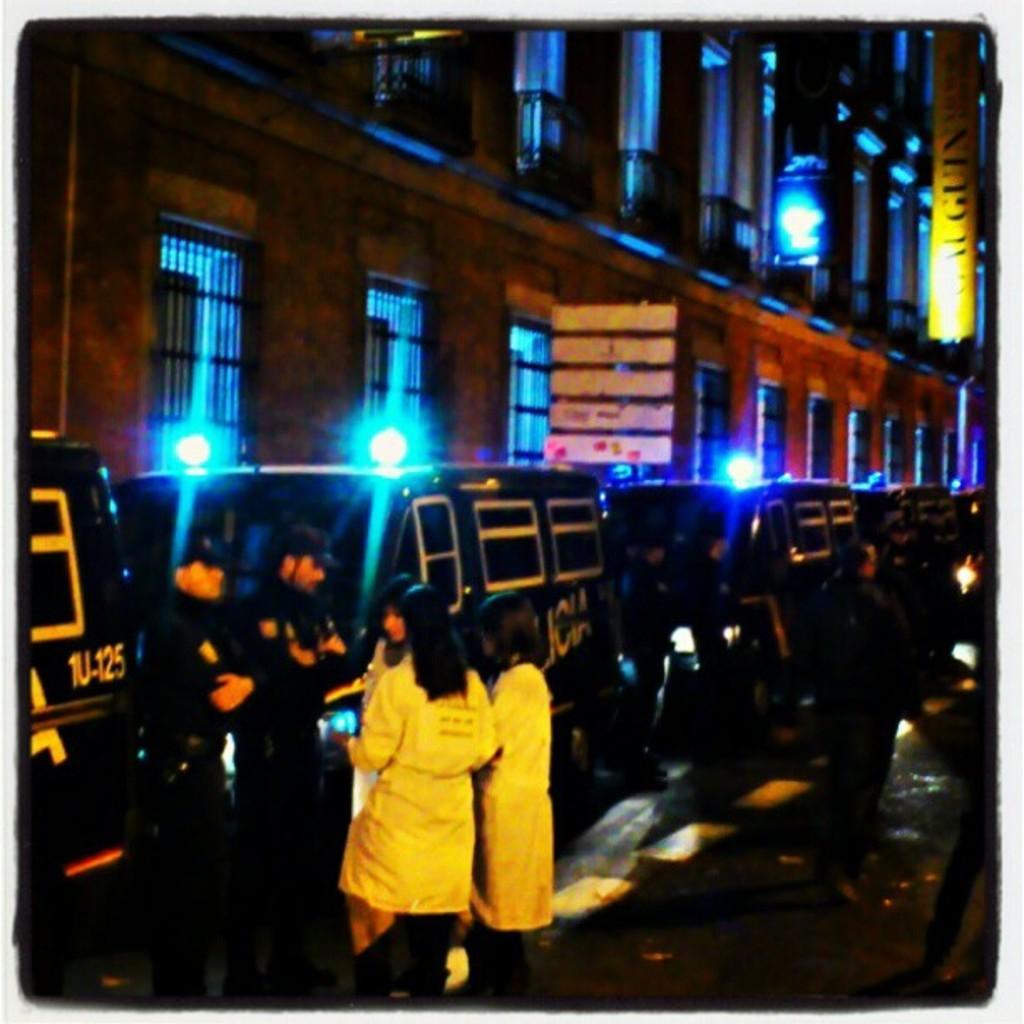Please provide a concise description of this image. This picture is clicked outside and seems to be an edited image with the borders and we can see the group of people standing on the ground. On the left there are many number of vehicles parked on the ground. In the background we can see the boards, lights and a building and we can see the windows of the building. 